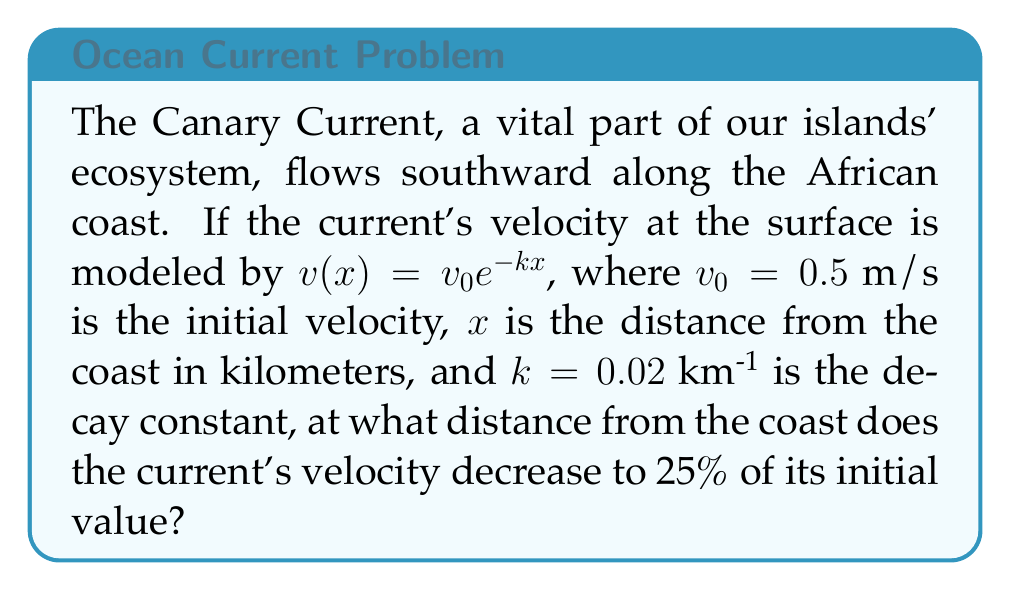What is the answer to this math problem? Let's approach this step-by-step:

1) We're given the velocity model: $v(x) = v_0 e^{-kx}$

2) We want to find $x$ when $v(x) = 0.25v_0$

3) Let's set up the equation:
   $0.25v_0 = v_0 e^{-kx}$

4) Divide both sides by $v_0$:
   $0.25 = e^{-kx}$

5) Take the natural logarithm of both sides:
   $\ln(0.25) = -kx$

6) Simplify the left side:
   $-1.386 = -kx$

7) Divide both sides by $-k$ (remember, $k = 0.02$ km^(-1)):
   $\frac{1.386}{0.02} = x$

8) Calculate the final result:
   $x = 69.3$ km

This distance represents where the Canary Current's velocity drops to 25% of its coastal value, highlighting the current's gradual weakening as it moves away from our islands.
Answer: 69.3 km 